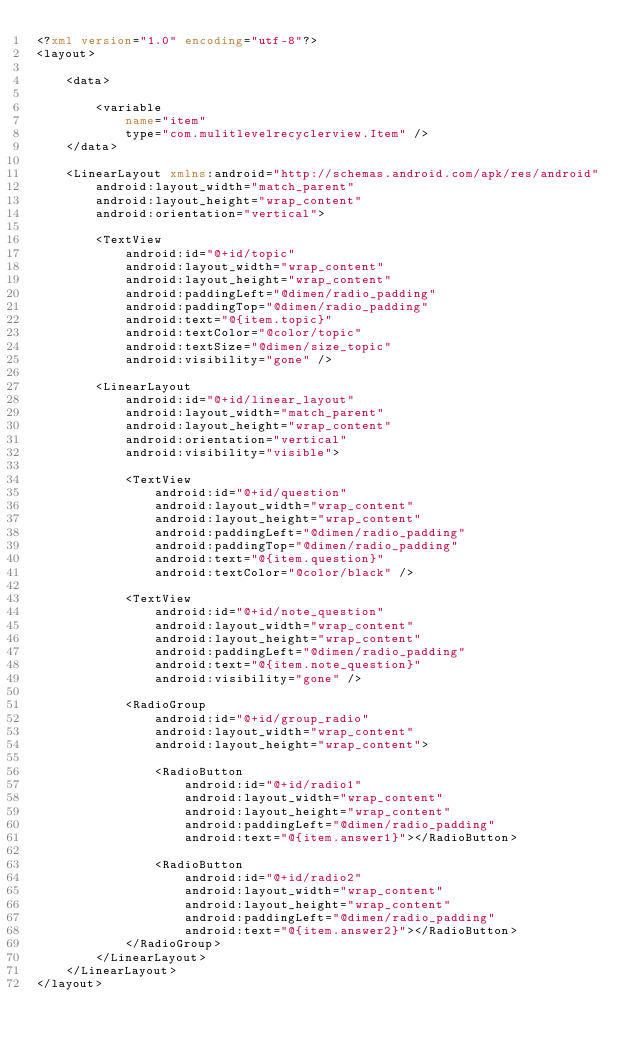<code> <loc_0><loc_0><loc_500><loc_500><_XML_><?xml version="1.0" encoding="utf-8"?>
<layout>

    <data>

        <variable
            name="item"
            type="com.mulitlevelrecyclerview.Item" />
    </data>

    <LinearLayout xmlns:android="http://schemas.android.com/apk/res/android"
        android:layout_width="match_parent"
        android:layout_height="wrap_content"
        android:orientation="vertical">

        <TextView
            android:id="@+id/topic"
            android:layout_width="wrap_content"
            android:layout_height="wrap_content"
            android:paddingLeft="@dimen/radio_padding"
            android:paddingTop="@dimen/radio_padding"
            android:text="@{item.topic}"
            android:textColor="@color/topic"
            android:textSize="@dimen/size_topic"
            android:visibility="gone" />

        <LinearLayout
            android:id="@+id/linear_layout"
            android:layout_width="match_parent"
            android:layout_height="wrap_content"
            android:orientation="vertical"
            android:visibility="visible">

            <TextView
                android:id="@+id/question"
                android:layout_width="wrap_content"
                android:layout_height="wrap_content"
                android:paddingLeft="@dimen/radio_padding"
                android:paddingTop="@dimen/radio_padding"
                android:text="@{item.question}"
                android:textColor="@color/black" />

            <TextView
                android:id="@+id/note_question"
                android:layout_width="wrap_content"
                android:layout_height="wrap_content"
                android:paddingLeft="@dimen/radio_padding"
                android:text="@{item.note_question}"
                android:visibility="gone" />

            <RadioGroup
                android:id="@+id/group_radio"
                android:layout_width="wrap_content"
                android:layout_height="wrap_content">

                <RadioButton
                    android:id="@+id/radio1"
                    android:layout_width="wrap_content"
                    android:layout_height="wrap_content"
                    android:paddingLeft="@dimen/radio_padding"
                    android:text="@{item.answer1}"></RadioButton>

                <RadioButton
                    android:id="@+id/radio2"
                    android:layout_width="wrap_content"
                    android:layout_height="wrap_content"
                    android:paddingLeft="@dimen/radio_padding"
                    android:text="@{item.answer2}"></RadioButton>
            </RadioGroup>
        </LinearLayout>
    </LinearLayout>
</layout></code> 